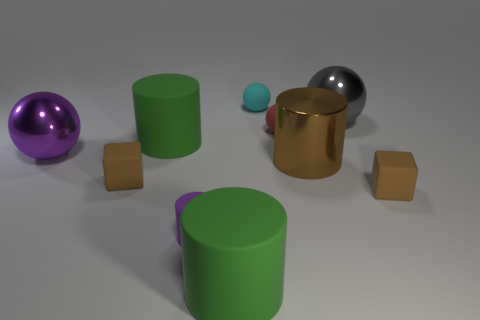Subtract all rubber cylinders. How many cylinders are left? 1 Subtract all red balls. How many balls are left? 3 Subtract all cylinders. How many objects are left? 6 Subtract all blue balls. How many red cubes are left? 0 Subtract all purple cylinders. Subtract all red matte objects. How many objects are left? 8 Add 8 tiny purple objects. How many tiny purple objects are left? 9 Add 7 brown matte objects. How many brown matte objects exist? 9 Subtract 1 brown cylinders. How many objects are left? 9 Subtract 3 balls. How many balls are left? 1 Subtract all brown balls. Subtract all red cylinders. How many balls are left? 4 